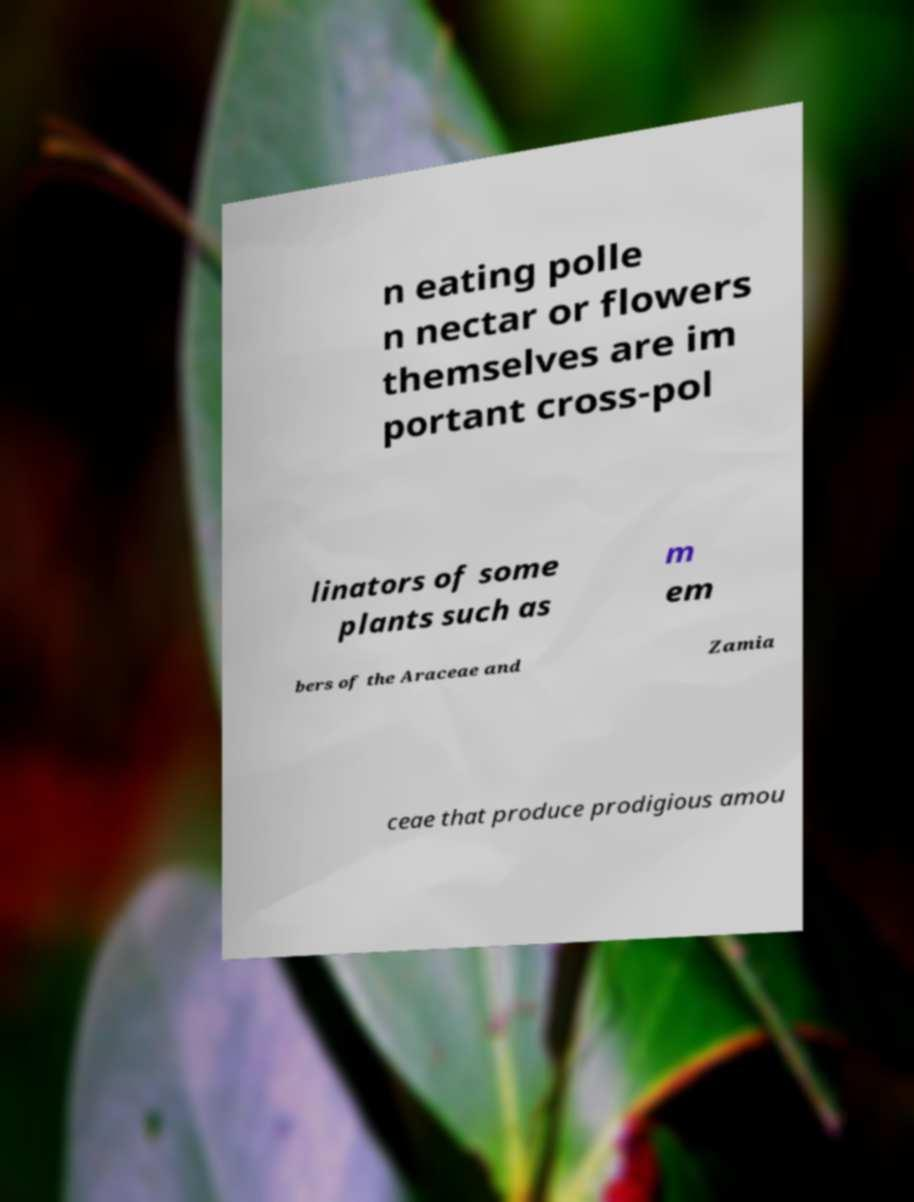Please read and relay the text visible in this image. What does it say? n eating polle n nectar or flowers themselves are im portant cross-pol linators of some plants such as m em bers of the Araceae and Zamia ceae that produce prodigious amou 